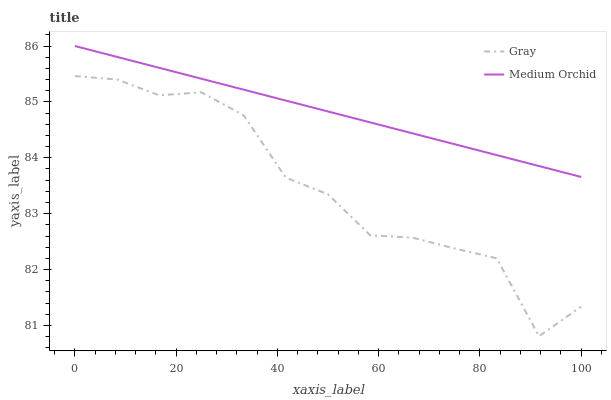Does Gray have the minimum area under the curve?
Answer yes or no. Yes. Does Medium Orchid have the maximum area under the curve?
Answer yes or no. Yes. Does Medium Orchid have the minimum area under the curve?
Answer yes or no. No. Is Medium Orchid the smoothest?
Answer yes or no. Yes. Is Gray the roughest?
Answer yes or no. Yes. Is Medium Orchid the roughest?
Answer yes or no. No. Does Gray have the lowest value?
Answer yes or no. Yes. Does Medium Orchid have the lowest value?
Answer yes or no. No. Does Medium Orchid have the highest value?
Answer yes or no. Yes. Is Gray less than Medium Orchid?
Answer yes or no. Yes. Is Medium Orchid greater than Gray?
Answer yes or no. Yes. Does Gray intersect Medium Orchid?
Answer yes or no. No. 